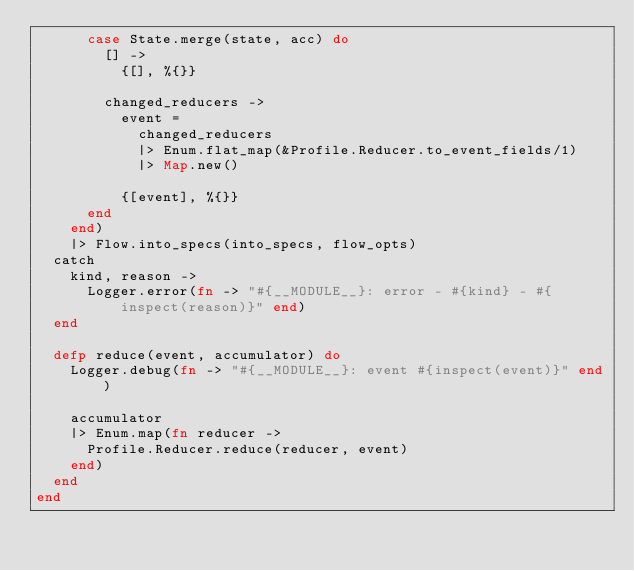Convert code to text. <code><loc_0><loc_0><loc_500><loc_500><_Elixir_>      case State.merge(state, acc) do
        [] ->
          {[], %{}}

        changed_reducers ->
          event =
            changed_reducers
            |> Enum.flat_map(&Profile.Reducer.to_event_fields/1)
            |> Map.new()

          {[event], %{}}
      end
    end)
    |> Flow.into_specs(into_specs, flow_opts)
  catch
    kind, reason ->
      Logger.error(fn -> "#{__MODULE__}: error - #{kind} - #{inspect(reason)}" end)
  end

  defp reduce(event, accumulator) do
    Logger.debug(fn -> "#{__MODULE__}: event #{inspect(event)}" end)

    accumulator
    |> Enum.map(fn reducer ->
      Profile.Reducer.reduce(reducer, event)
    end)
  end
end
</code> 